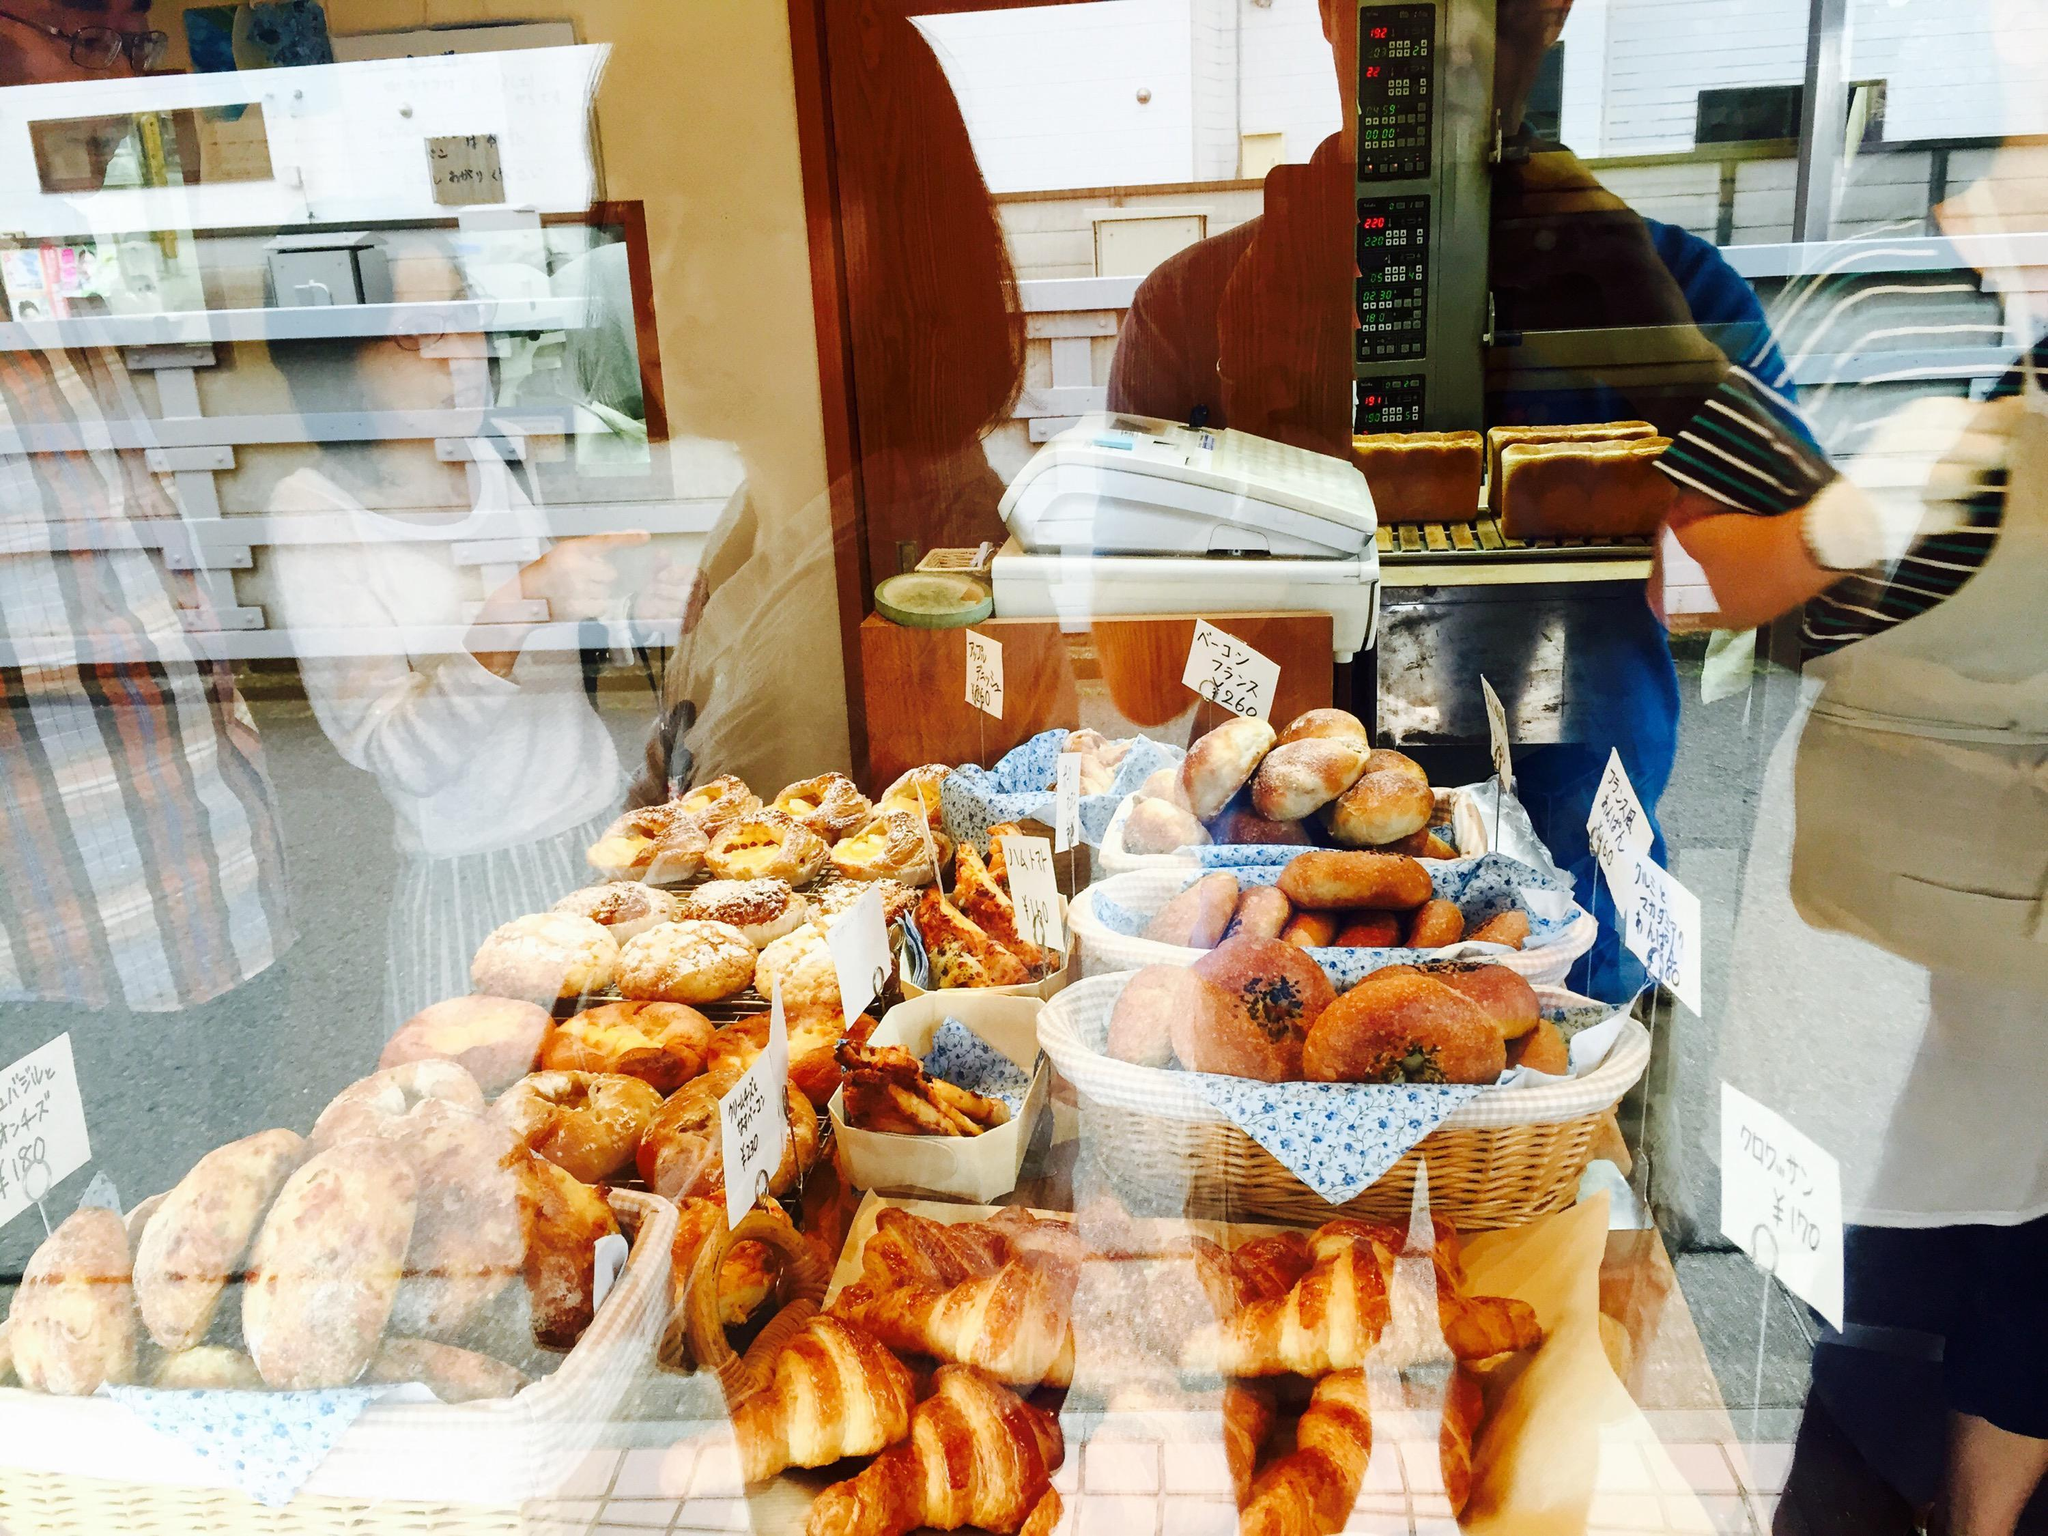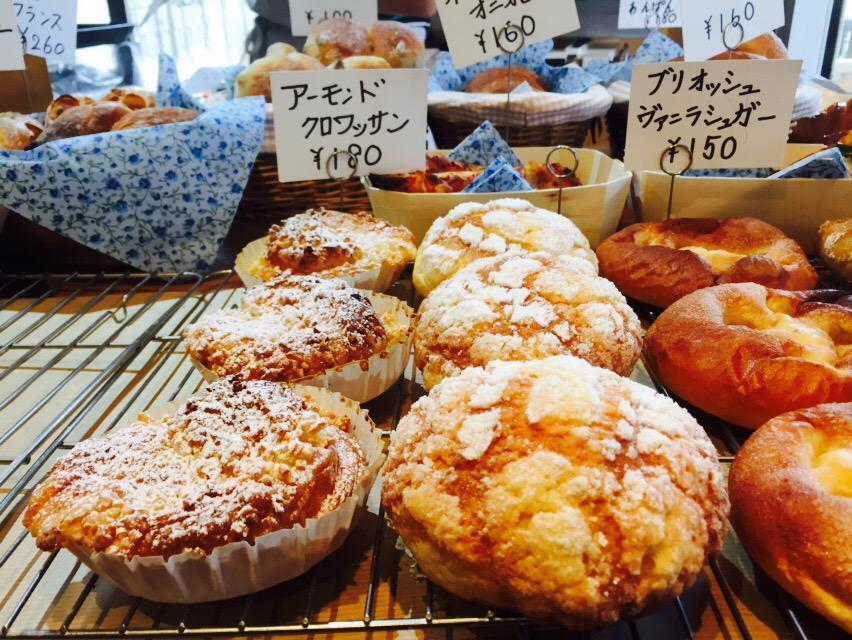The first image is the image on the left, the second image is the image on the right. For the images shown, is this caption "There are no more than five pastries." true? Answer yes or no. No. The first image is the image on the left, the second image is the image on the right. Considering the images on both sides, is "One image contains exactly two round roll-type items displayed horizontally and side-by-side." valid? Answer yes or no. No. 